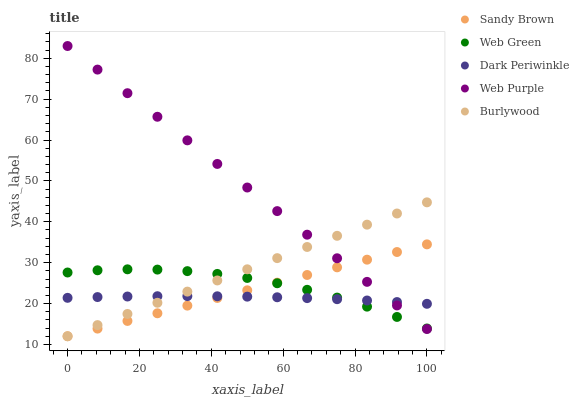Does Dark Periwinkle have the minimum area under the curve?
Answer yes or no. Yes. Does Web Purple have the maximum area under the curve?
Answer yes or no. Yes. Does Sandy Brown have the minimum area under the curve?
Answer yes or no. No. Does Sandy Brown have the maximum area under the curve?
Answer yes or no. No. Is Sandy Brown the smoothest?
Answer yes or no. Yes. Is Web Green the roughest?
Answer yes or no. Yes. Is Web Purple the smoothest?
Answer yes or no. No. Is Web Purple the roughest?
Answer yes or no. No. Does Burlywood have the lowest value?
Answer yes or no. Yes. Does Web Purple have the lowest value?
Answer yes or no. No. Does Web Purple have the highest value?
Answer yes or no. Yes. Does Sandy Brown have the highest value?
Answer yes or no. No. Does Burlywood intersect Web Green?
Answer yes or no. Yes. Is Burlywood less than Web Green?
Answer yes or no. No. Is Burlywood greater than Web Green?
Answer yes or no. No. 